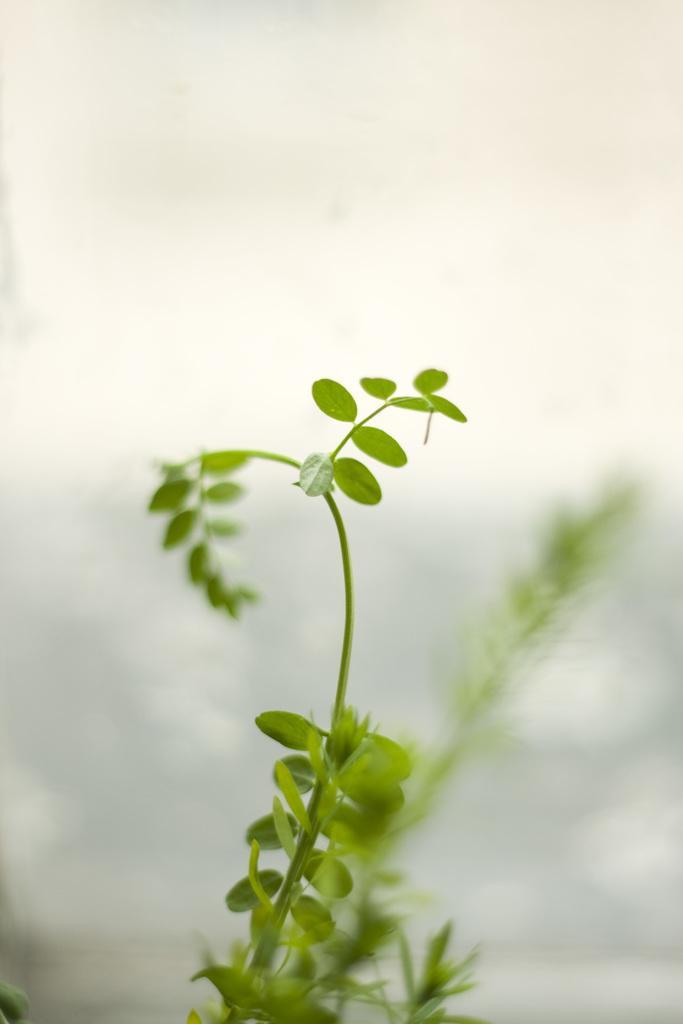In one or two sentences, can you explain what this image depicts? In this picture we can see leaves of a plant in the front, there is a blurry background. 